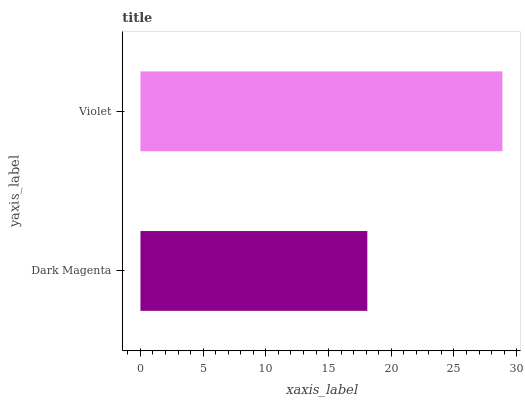Is Dark Magenta the minimum?
Answer yes or no. Yes. Is Violet the maximum?
Answer yes or no. Yes. Is Violet the minimum?
Answer yes or no. No. Is Violet greater than Dark Magenta?
Answer yes or no. Yes. Is Dark Magenta less than Violet?
Answer yes or no. Yes. Is Dark Magenta greater than Violet?
Answer yes or no. No. Is Violet less than Dark Magenta?
Answer yes or no. No. Is Violet the high median?
Answer yes or no. Yes. Is Dark Magenta the low median?
Answer yes or no. Yes. Is Dark Magenta the high median?
Answer yes or no. No. Is Violet the low median?
Answer yes or no. No. 